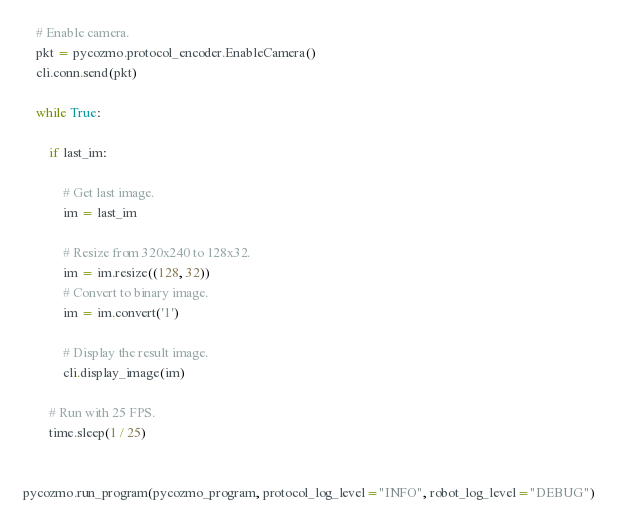<code> <loc_0><loc_0><loc_500><loc_500><_Python_>
    # Enable camera.
    pkt = pycozmo.protocol_encoder.EnableCamera()
    cli.conn.send(pkt)

    while True:

        if last_im:

            # Get last image.
            im = last_im

            # Resize from 320x240 to 128x32.
            im = im.resize((128, 32))
            # Convert to binary image.
            im = im.convert('1')

            # Display the result image.
            cli.display_image(im)

        # Run with 25 FPS.
        time.sleep(1 / 25)


pycozmo.run_program(pycozmo_program, protocol_log_level="INFO", robot_log_level="DEBUG")
</code> 